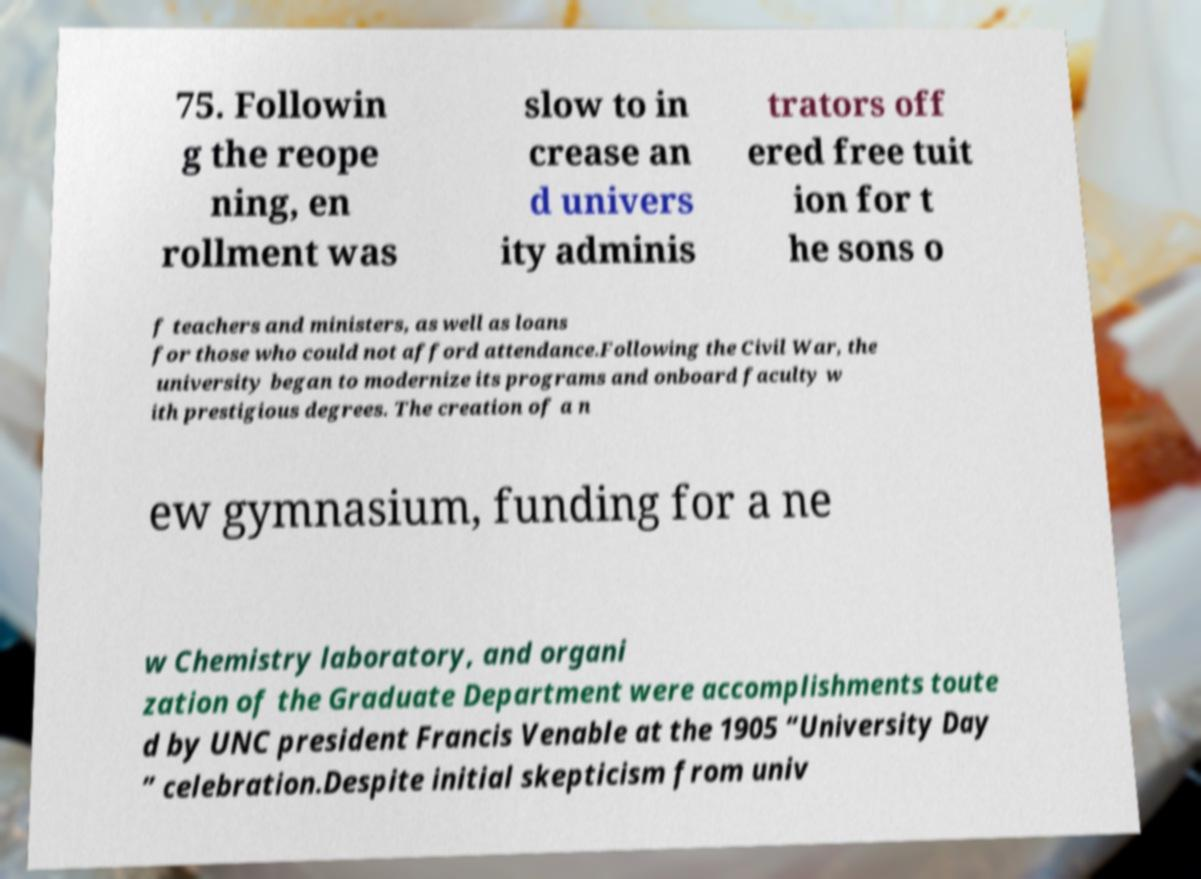There's text embedded in this image that I need extracted. Can you transcribe it verbatim? 75. Followin g the reope ning, en rollment was slow to in crease an d univers ity adminis trators off ered free tuit ion for t he sons o f teachers and ministers, as well as loans for those who could not afford attendance.Following the Civil War, the university began to modernize its programs and onboard faculty w ith prestigious degrees. The creation of a n ew gymnasium, funding for a ne w Chemistry laboratory, and organi zation of the Graduate Department were accomplishments toute d by UNC president Francis Venable at the 1905 “University Day ” celebration.Despite initial skepticism from univ 